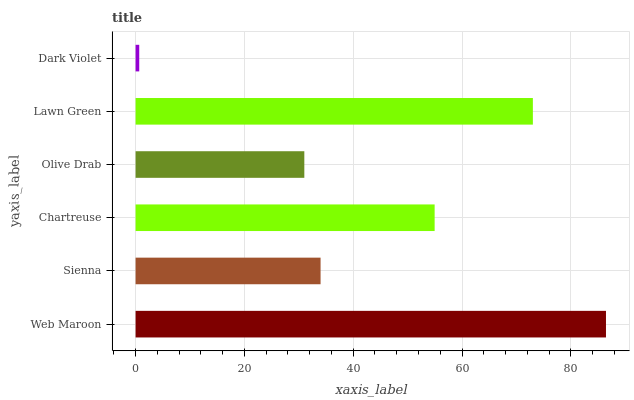Is Dark Violet the minimum?
Answer yes or no. Yes. Is Web Maroon the maximum?
Answer yes or no. Yes. Is Sienna the minimum?
Answer yes or no. No. Is Sienna the maximum?
Answer yes or no. No. Is Web Maroon greater than Sienna?
Answer yes or no. Yes. Is Sienna less than Web Maroon?
Answer yes or no. Yes. Is Sienna greater than Web Maroon?
Answer yes or no. No. Is Web Maroon less than Sienna?
Answer yes or no. No. Is Chartreuse the high median?
Answer yes or no. Yes. Is Sienna the low median?
Answer yes or no. Yes. Is Web Maroon the high median?
Answer yes or no. No. Is Dark Violet the low median?
Answer yes or no. No. 